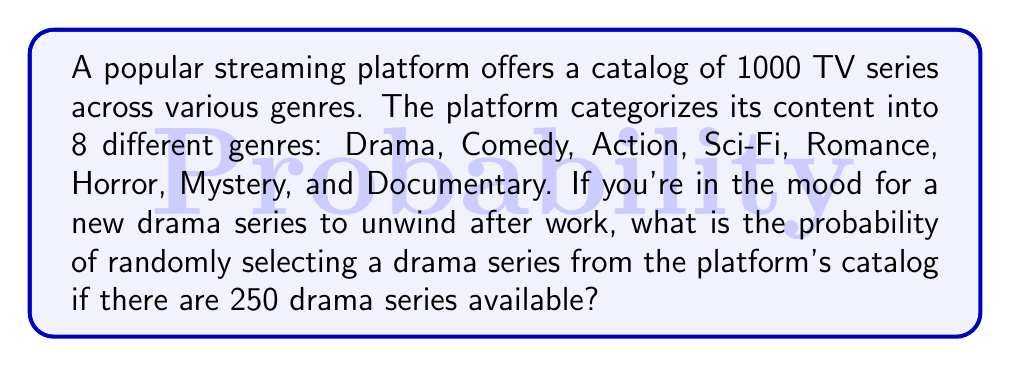What is the answer to this math problem? Let's approach this step-by-step:

1. First, we need to identify the key information:
   - Total number of TV series: 1000
   - Number of drama series: 250

2. The probability of an event is calculated by dividing the number of favorable outcomes by the total number of possible outcomes:

   $$ P(\text{event}) = \frac{\text{number of favorable outcomes}}{\text{total number of possible outcomes}} $$

3. In this case:
   - Favorable outcomes: selecting a drama series (250)
   - Total possible outcomes: selecting any series from the catalog (1000)

4. Plugging these numbers into our probability formula:

   $$ P(\text{selecting a drama series}) = \frac{250}{1000} $$

5. Simplify the fraction:

   $$ P(\text{selecting a drama series}) = \frac{1}{4} = 0.25 $$

6. Convert to a percentage:

   $$ 0.25 \times 100\% = 25\% $$

Therefore, the probability of randomly selecting a drama series from the platform's catalog is 0.25 or 25%.
Answer: $\frac{1}{4}$ or 0.25 or 25% 